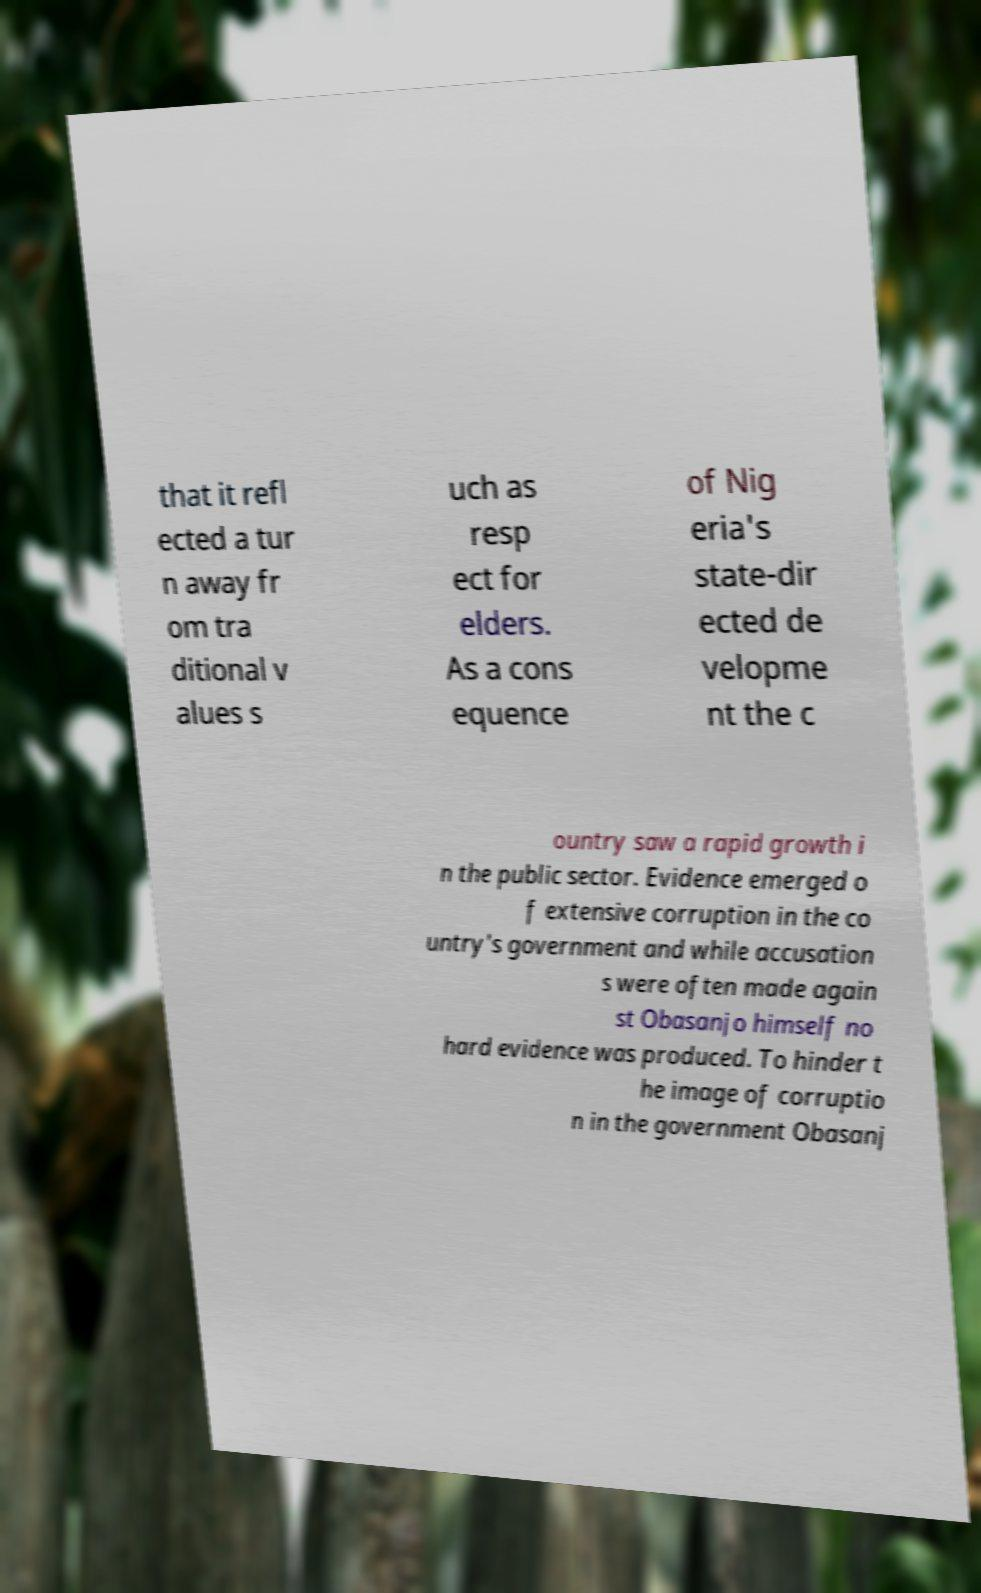For documentation purposes, I need the text within this image transcribed. Could you provide that? that it refl ected a tur n away fr om tra ditional v alues s uch as resp ect for elders. As a cons equence of Nig eria's state-dir ected de velopme nt the c ountry saw a rapid growth i n the public sector. Evidence emerged o f extensive corruption in the co untry's government and while accusation s were often made again st Obasanjo himself no hard evidence was produced. To hinder t he image of corruptio n in the government Obasanj 